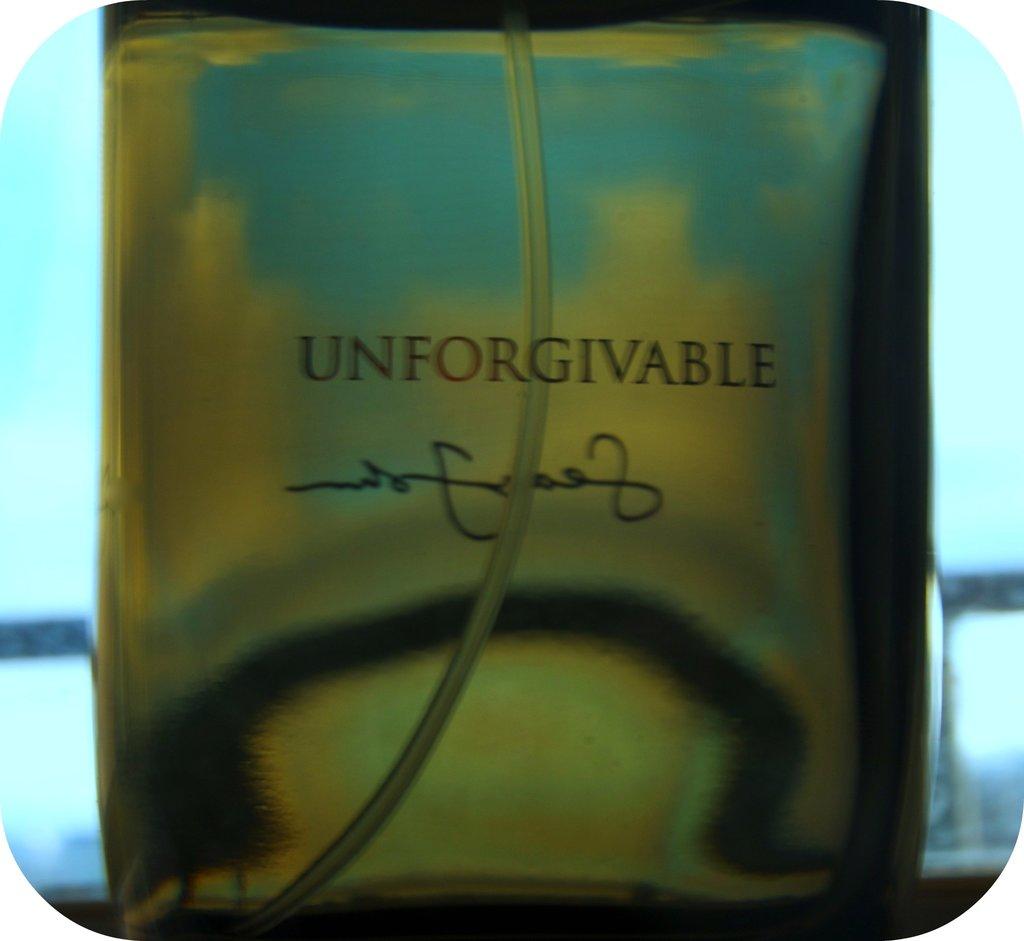What is written above the signature?
Your response must be concise. Unforgivable. 